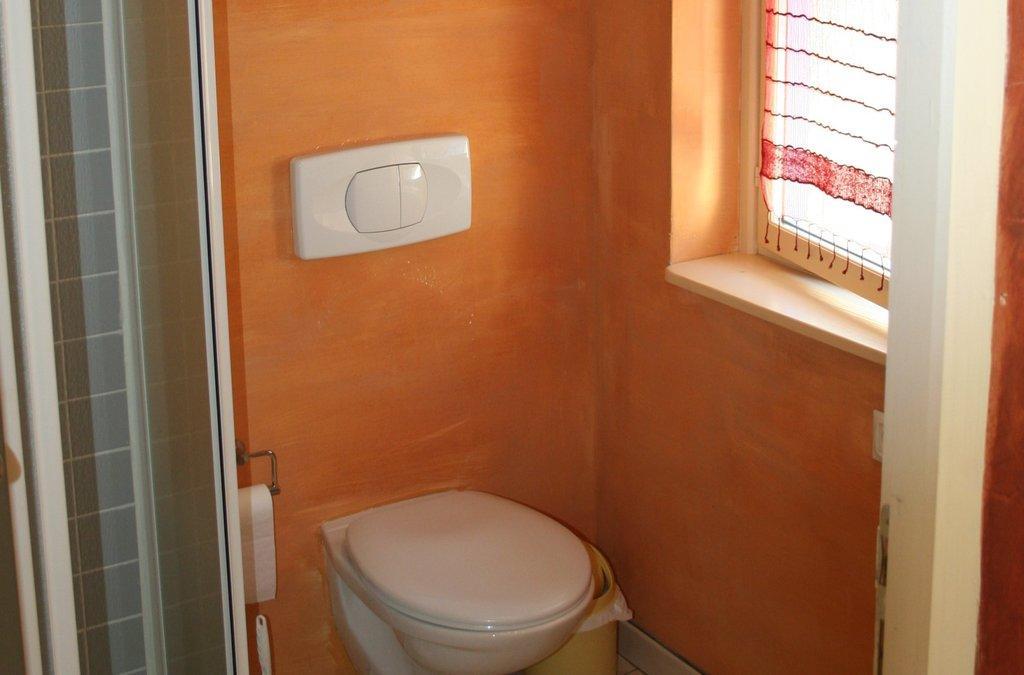Can you describe this image briefly? This picture was taken inside the washroom. Here is the toilet seat. I think this is the dustbin, which is at the corner. This looks like a tissue paper roll, which is hanging to the hanger. I can see the flush button, which is attached to the wall. This is the window. I think this is the door. 